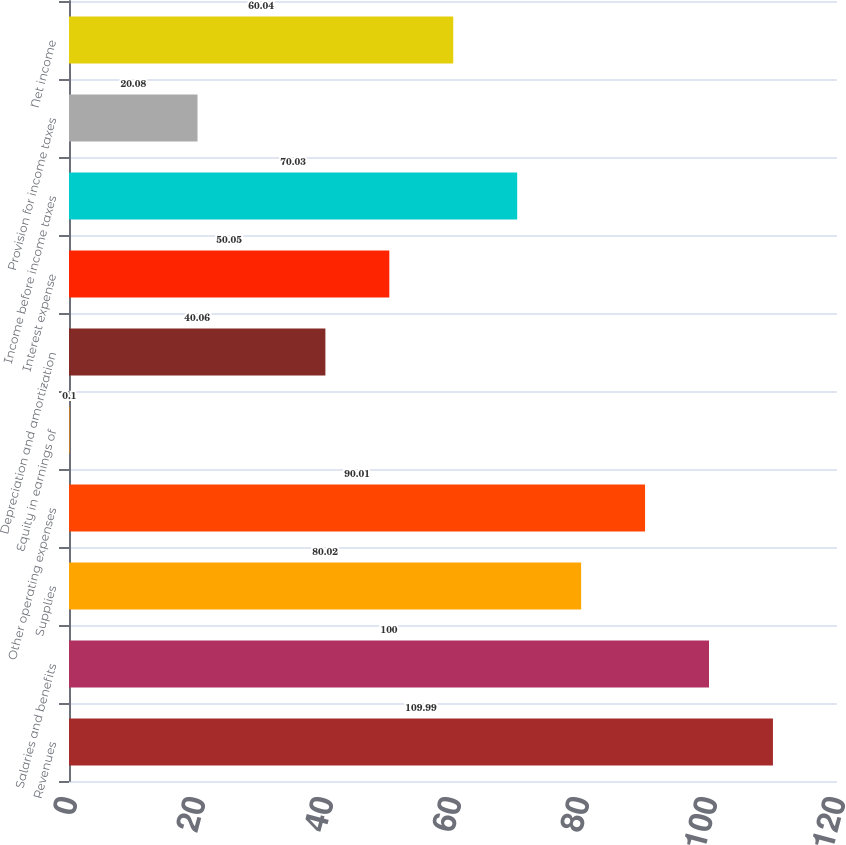Convert chart. <chart><loc_0><loc_0><loc_500><loc_500><bar_chart><fcel>Revenues<fcel>Salaries and benefits<fcel>Supplies<fcel>Other operating expenses<fcel>Equity in earnings of<fcel>Depreciation and amortization<fcel>Interest expense<fcel>Income before income taxes<fcel>Provision for income taxes<fcel>Net income<nl><fcel>109.99<fcel>100<fcel>80.02<fcel>90.01<fcel>0.1<fcel>40.06<fcel>50.05<fcel>70.03<fcel>20.08<fcel>60.04<nl></chart> 